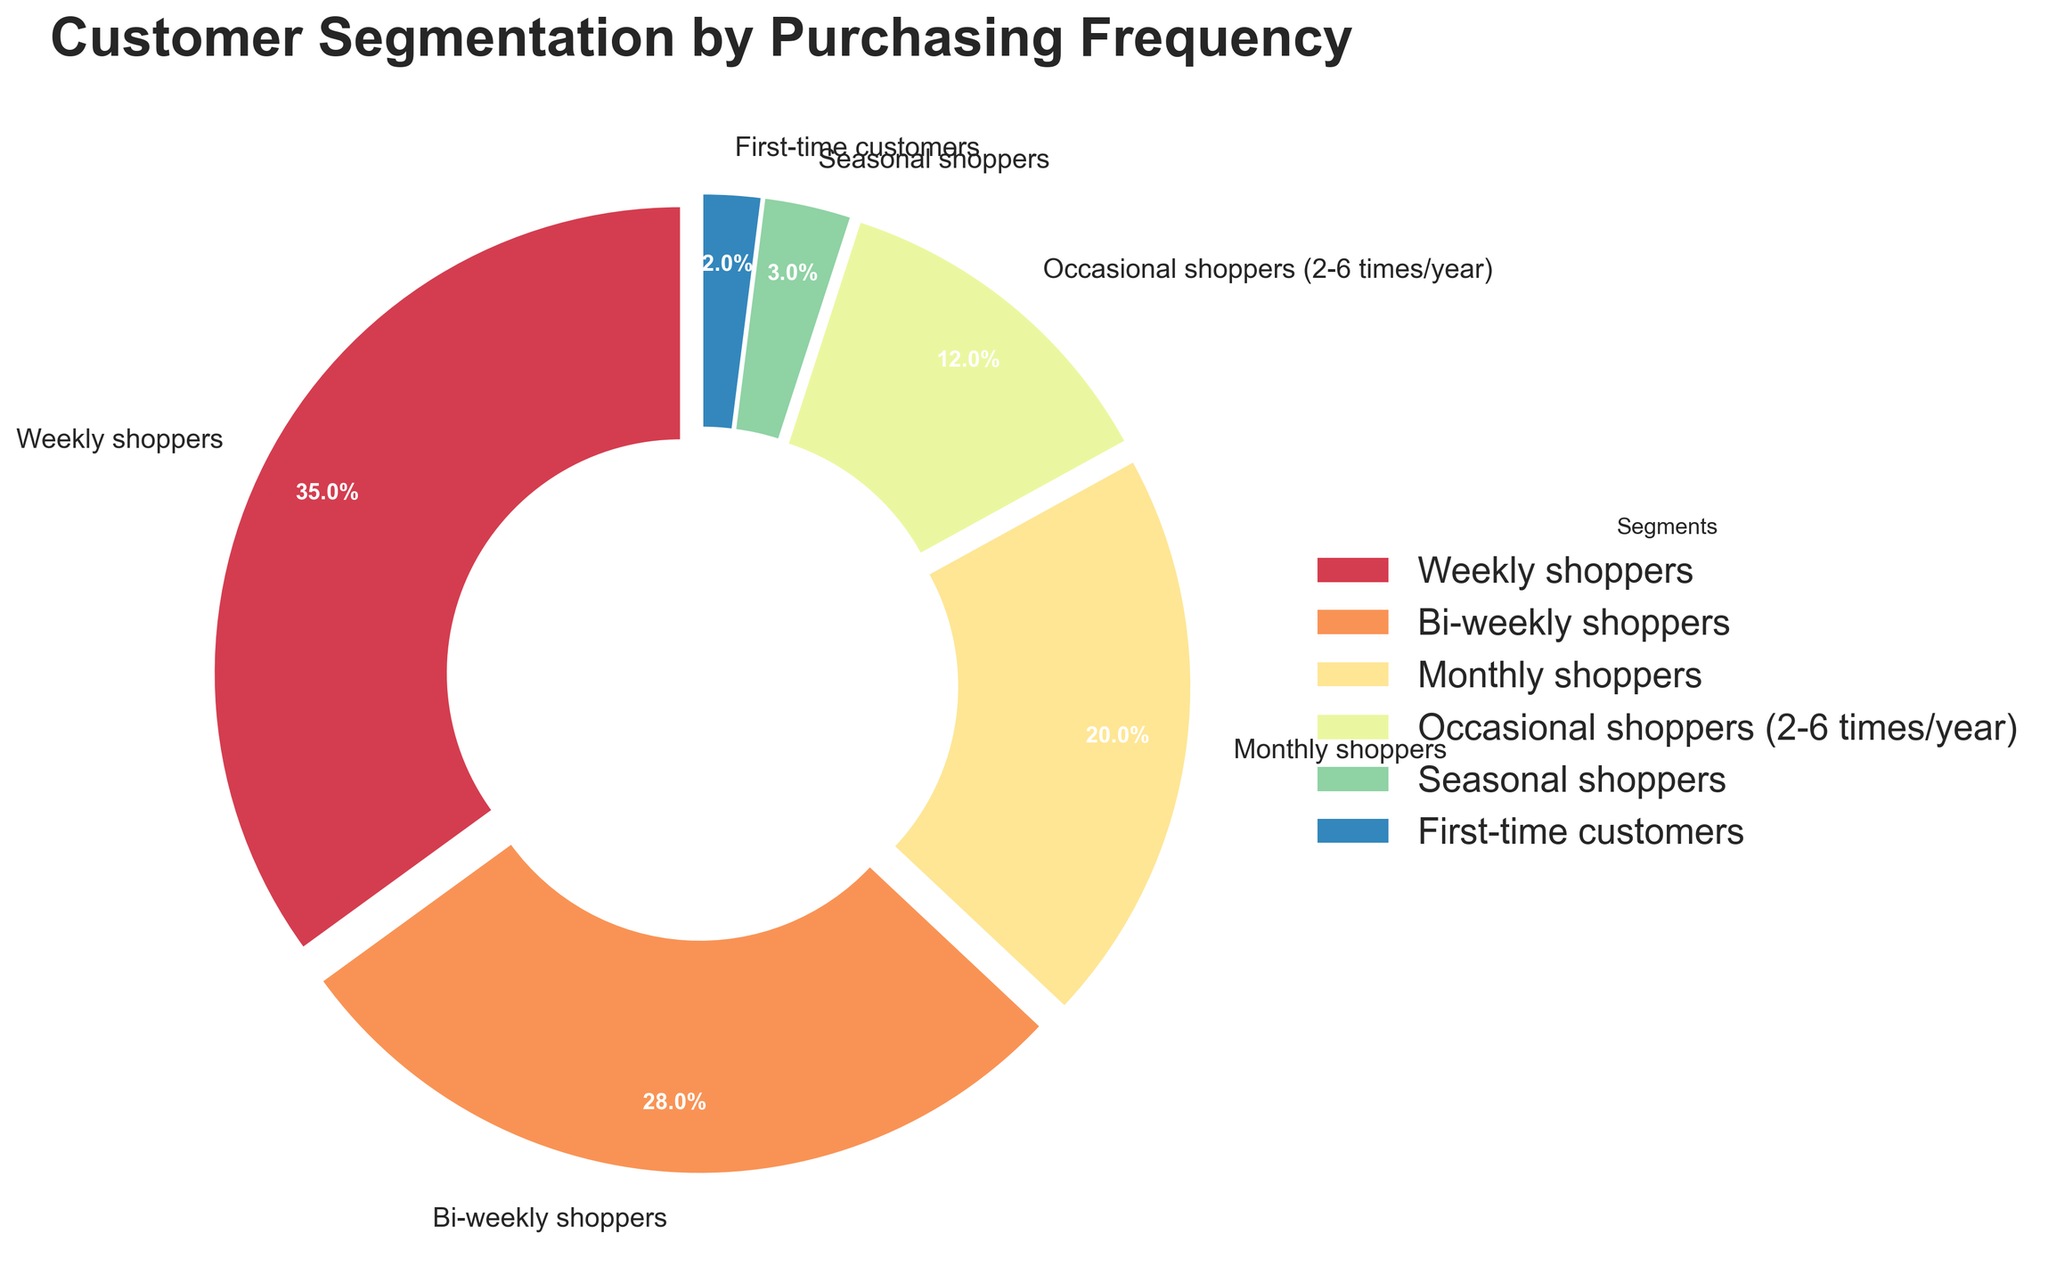What percentage of customers shop weekly and bi-weekly combined? Add the percentages of weekly shoppers (35%) and bi-weekly shoppers (28%) together: 35 + 28 = 63
Answer: 63 Which customer segment has the lowest purchasing frequency? Identify the segment with the smallest percentage. First-time customers have the lowest percentage at 2%
Answer: First-time customers Compare the percentage of monthly shoppers to that of occasional shoppers. Which is higher, and by how much? Monthly shoppers are 20% and occasional shoppers are 12%. Subtract to find the difference: 20 - 12 = 8. Monthly shoppers are higher
Answer: Monthly shoppers by 8% What is the total percentage of shoppers who shop either seasonally or for the first time? Add the percentages of seasonal shoppers (3%) and first-time customers (2%) together: 3 + 2 = 5
Answer: 5 What is the ratio of weekly shoppers to monthly shoppers? Weekly shoppers are 35% and monthly shoppers are 20%. Divide the percentages to find the ratio: 35 / 20 = 1.75
Answer: 1.75 Which segment occupies the largest section of the pie chart? The segment with the highest percentage is the largest on the pie chart. Weekly shoppers have the highest percentage at 35%
Answer: Weekly shoppers How many times greater is the percentage of bi-weekly shoppers compared to first-time customers? Bi-weekly shoppers are 28% and first-time customers are 2%. Divide the former by the latter: 28 / 2 = 14
Answer: 14 Determine the combined share of the three highest customer segments in terms of purchasing frequency. Weekly shoppers (35%), bi-weekly shoppers (28%), and monthly shoppers (20%) are the top three segments. Add their percentages: 35 + 28 + 20 = 83
Answer: 83 What percentage of the total do occasional shoppers and seasonal shoppers make up together? Occasional shoppers are 12% and seasonal shoppers are 3%. Add the percentages: 12 + 3 = 15
Answer: 15 If we merge occasional and seasonal shoppers into a single segment, would this new segment be the second smallest group? The new segment would have a combined percentage of 12% (occasional) + 3% (seasonal) = 15%. Compare with the existing segments: First-time customers (2%), seasonal shoppers (3%). 15% is greater than these two but less than bi-weekly shoppers (28%), monthly shoppers (20%), and weekly shoppers (35%). So, it is the second smallest
Answer: Yes 